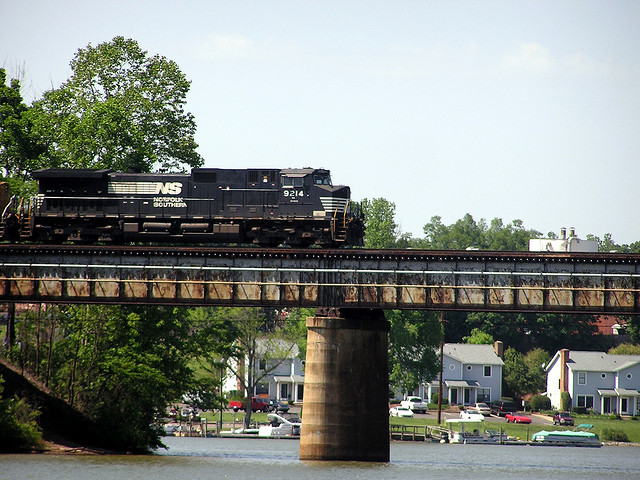Identify the text displayed in this image. 9214 NS SOUTHERN 